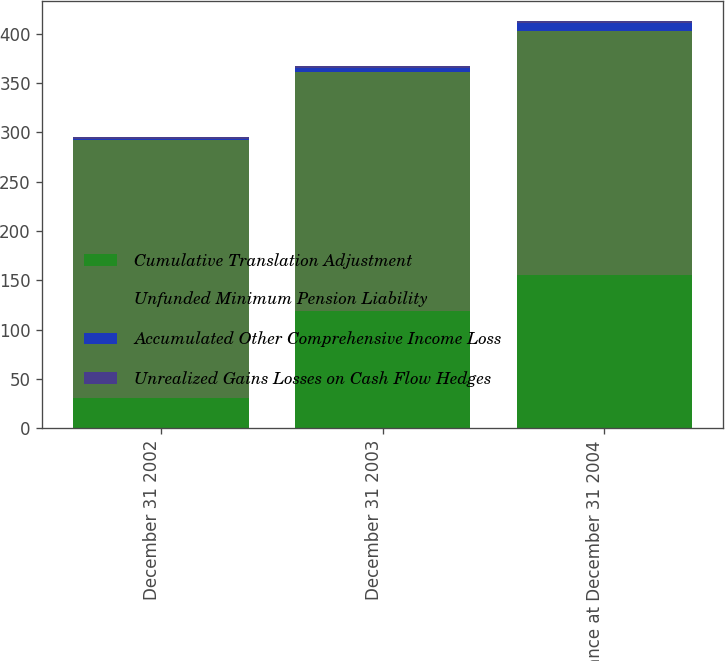<chart> <loc_0><loc_0><loc_500><loc_500><stacked_bar_chart><ecel><fcel>December 31 2002<fcel>December 31 2003<fcel>Balance at December 31 2004<nl><fcel>Cumulative Translation Adjustment<fcel>31<fcel>119<fcel>155<nl><fcel>Unfunded Minimum Pension Liability<fcel>261<fcel>242<fcel>248<nl><fcel>Accumulated Other Comprehensive Income Loss<fcel>1<fcel>4<fcel>8<nl><fcel>Unrealized Gains Losses on Cash Flow Hedges<fcel>2<fcel>2<fcel>2<nl></chart> 